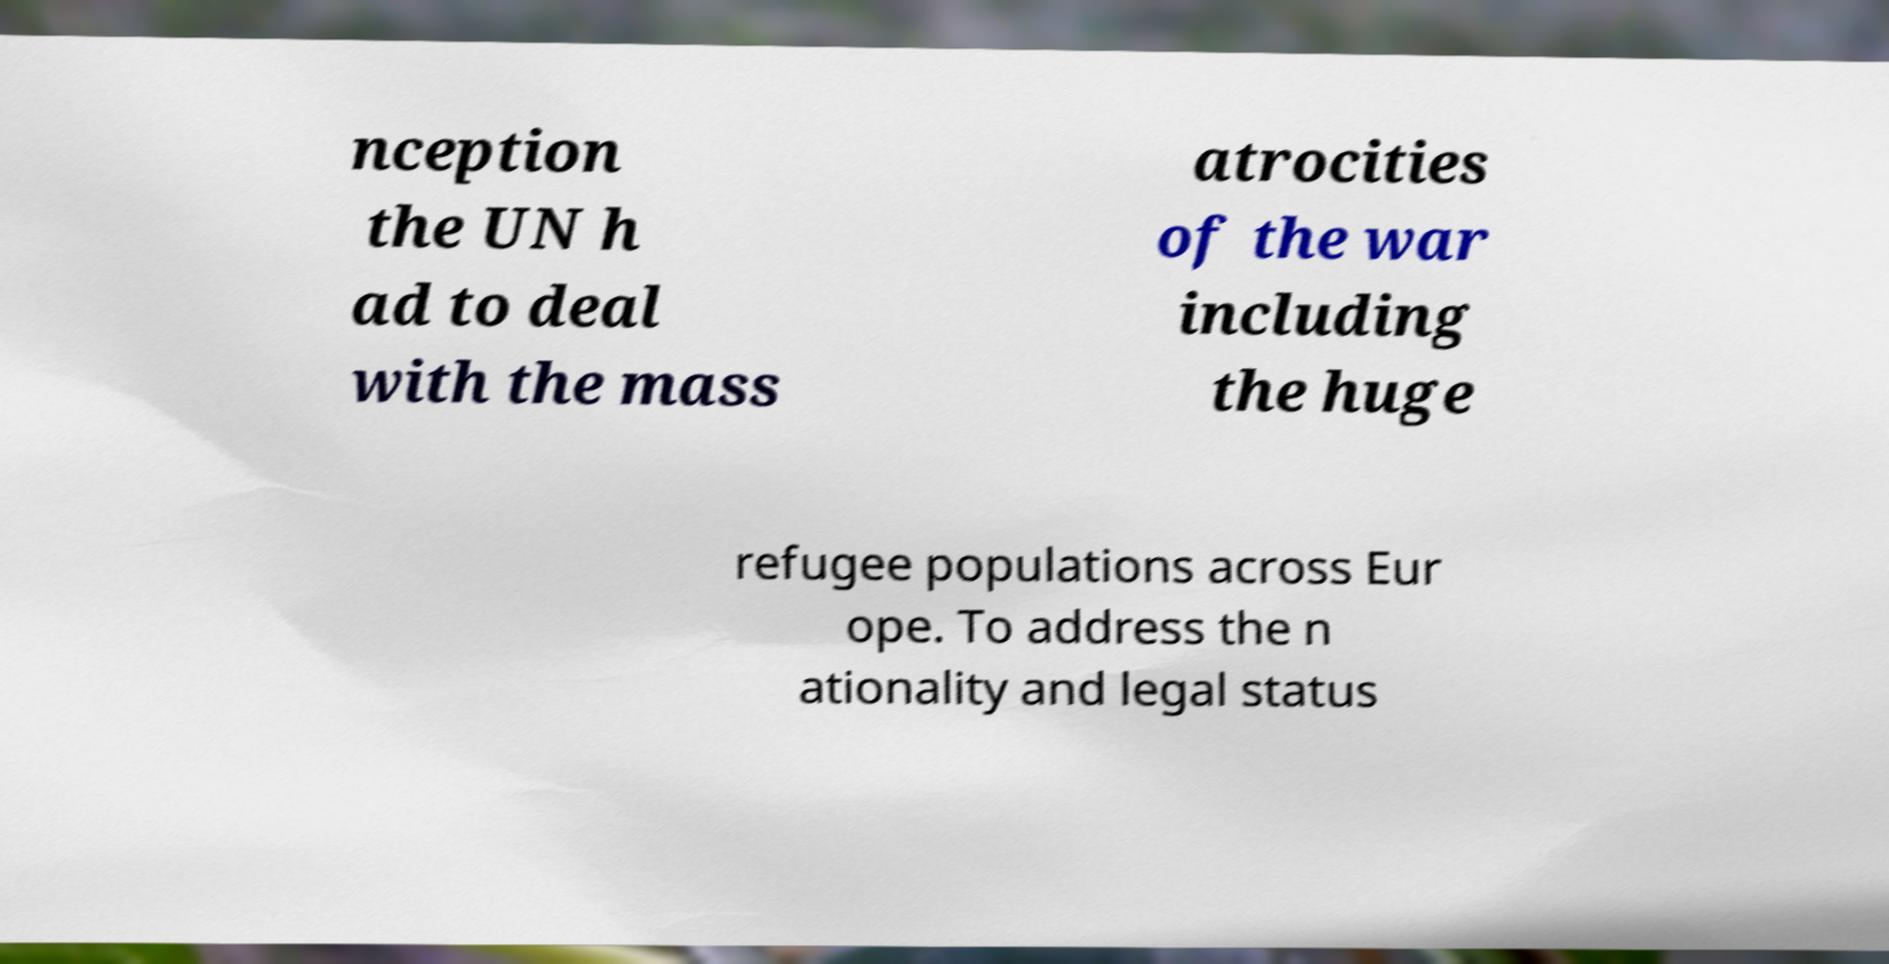Please identify and transcribe the text found in this image. nception the UN h ad to deal with the mass atrocities of the war including the huge refugee populations across Eur ope. To address the n ationality and legal status 